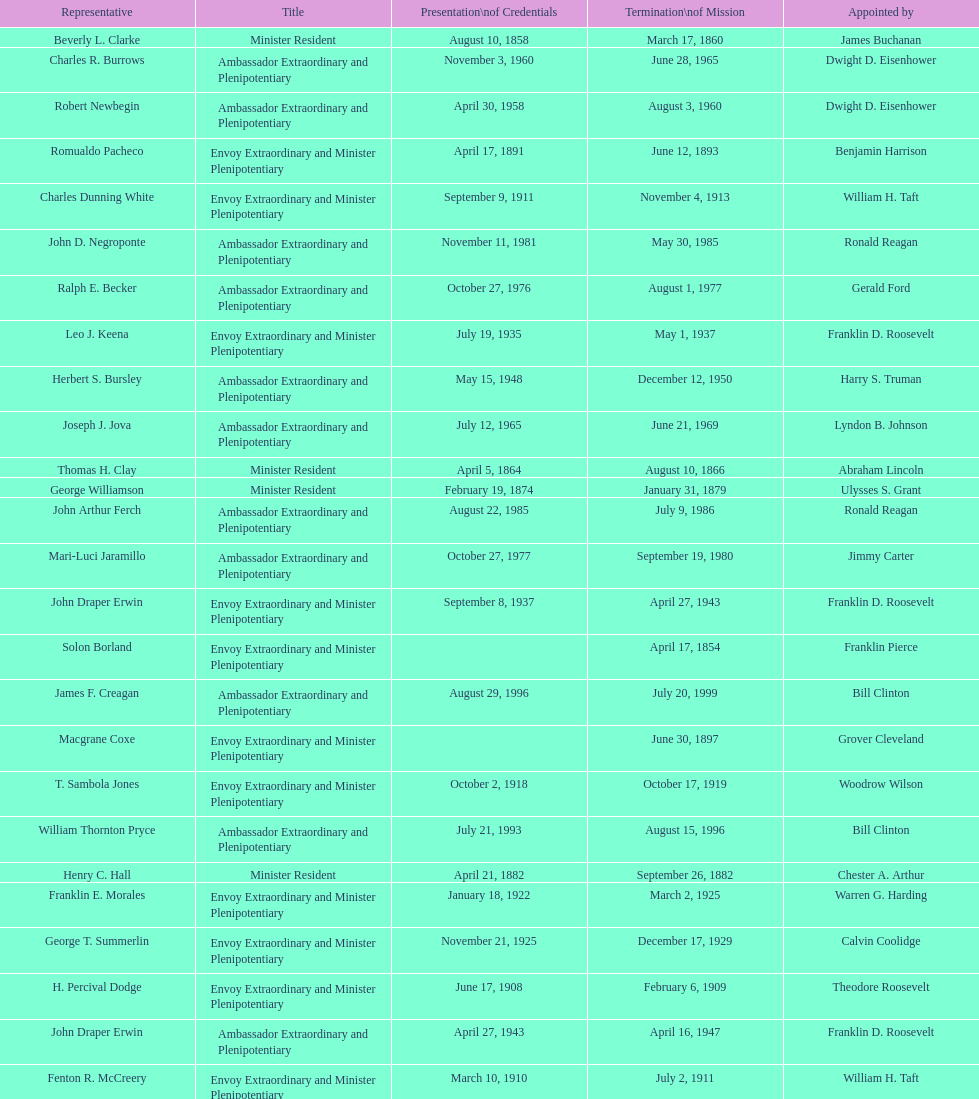Which envoy was the first appointed by woodrow wilson? John Ewing. 